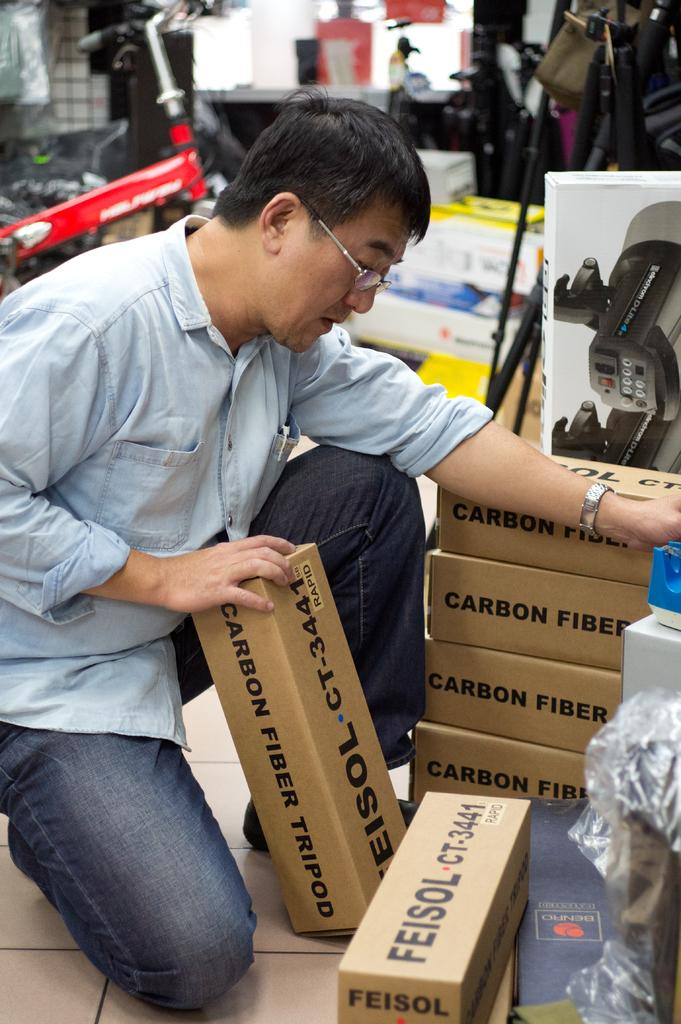Who is present in the image? There is a man in the image. What type of containers can be seen in the image? There are cartons in the image. What mode of transportation is visible in the image? There is a bicycle in the image. Can you describe any other objects visible in the image? There are other objects visible in the image, but their specific details are not mentioned in the provided facts. Where is the map located in the image? There is no map present in the image. What type of hat is the man wearing in the image? The man's hat is not mentioned in the provided facts, so we cannot determine if he is wearing a hat or what type it is. 